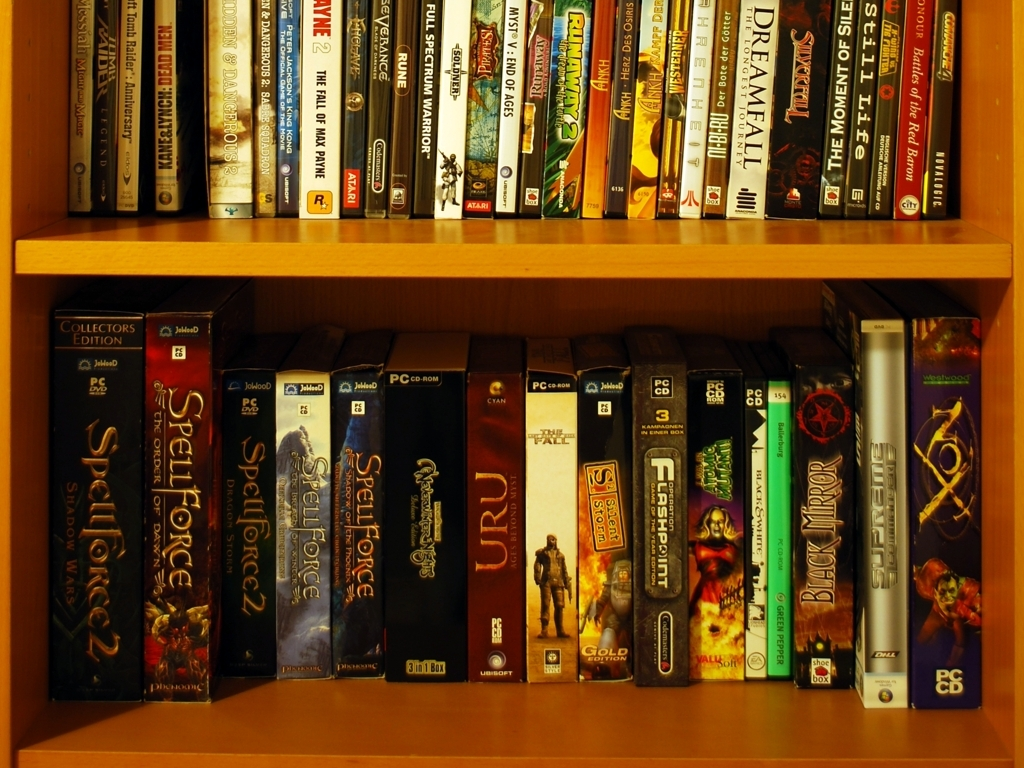Is the lighting in the image poor? The image showcases a clear and vibrant display of video game cases on a shelf with ample illumination highlighting the title text and artwork on the spines of the cases. Given the visibility of the details and the absence of harsh shadows or overexposed areas, the lighting can be considered quite adequate for perceiving all the elements in the photo. 